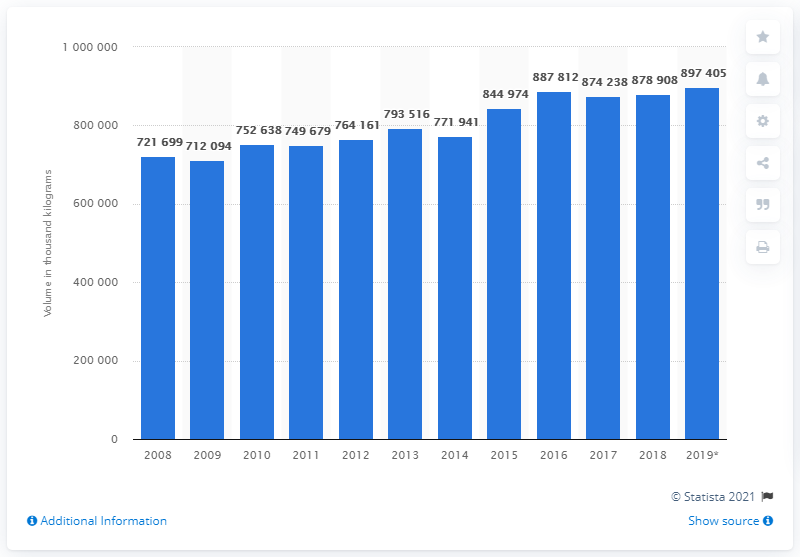Give some essential details in this illustration. Production volumes in the Netherlands peaked in 2016. 